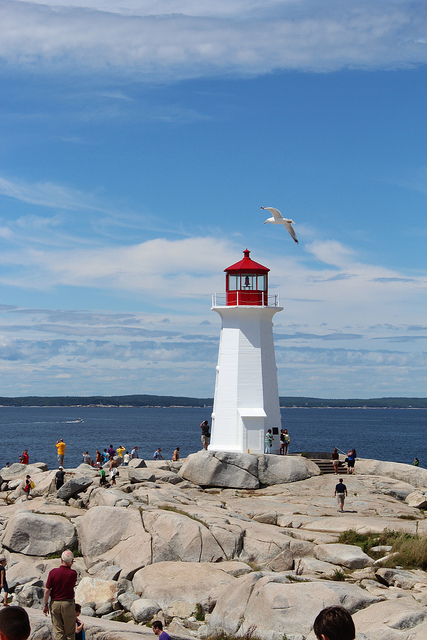Can you tell what time of the day it might be in this scene? Given the brightness of the scene and the shadows cast by the people and the lighthouse, it appears to be midday or early afternoon when the sun is relatively high in the sky. 